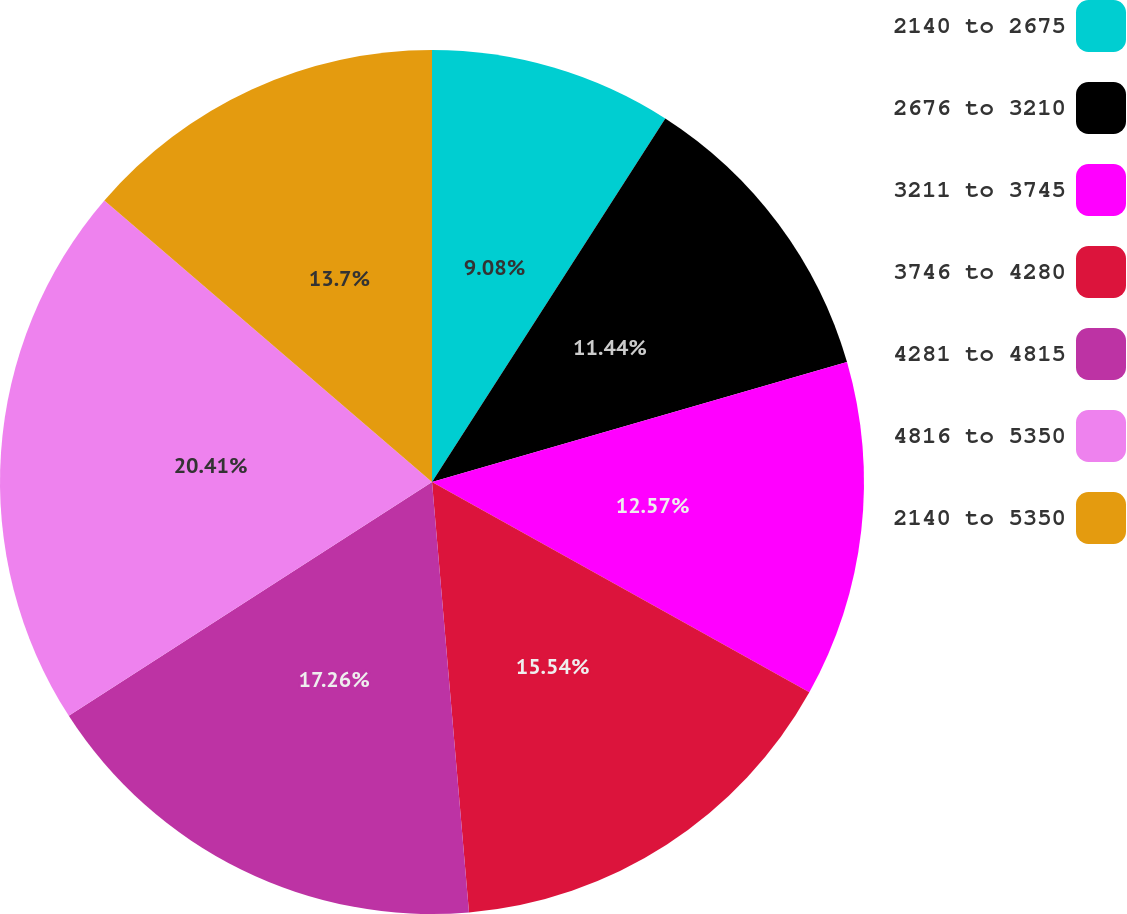Convert chart. <chart><loc_0><loc_0><loc_500><loc_500><pie_chart><fcel>2140 to 2675<fcel>2676 to 3210<fcel>3211 to 3745<fcel>3746 to 4280<fcel>4281 to 4815<fcel>4816 to 5350<fcel>2140 to 5350<nl><fcel>9.08%<fcel>11.44%<fcel>12.57%<fcel>15.54%<fcel>17.26%<fcel>20.4%<fcel>13.7%<nl></chart> 